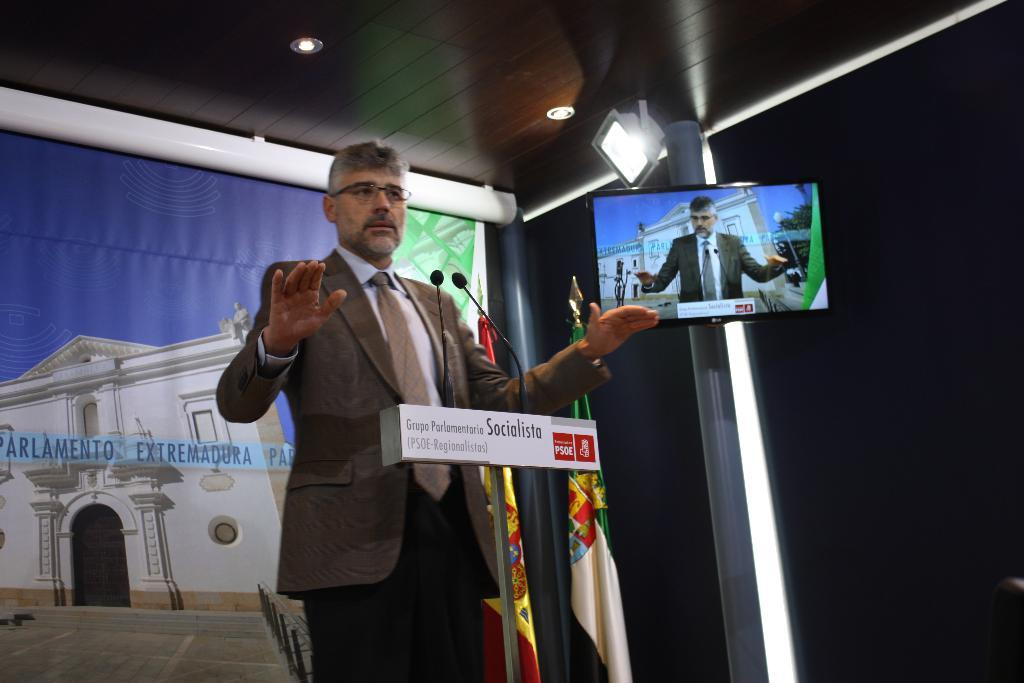Who is the main subject in the image? There is a man in the image. What is the man wearing? The man is wearing a suit. What is the man doing in the image? The man is standing in front of a podium. What can be seen in the background of the image? There is a poster and a TV in the background of the image. Who is visible on the TV? There is a man visible on the TV. What type of seed is being planted by the man in the image? There is no seed or planting activity depicted in the image. The man is standing in front of a podium, and there is a TV in the background. 